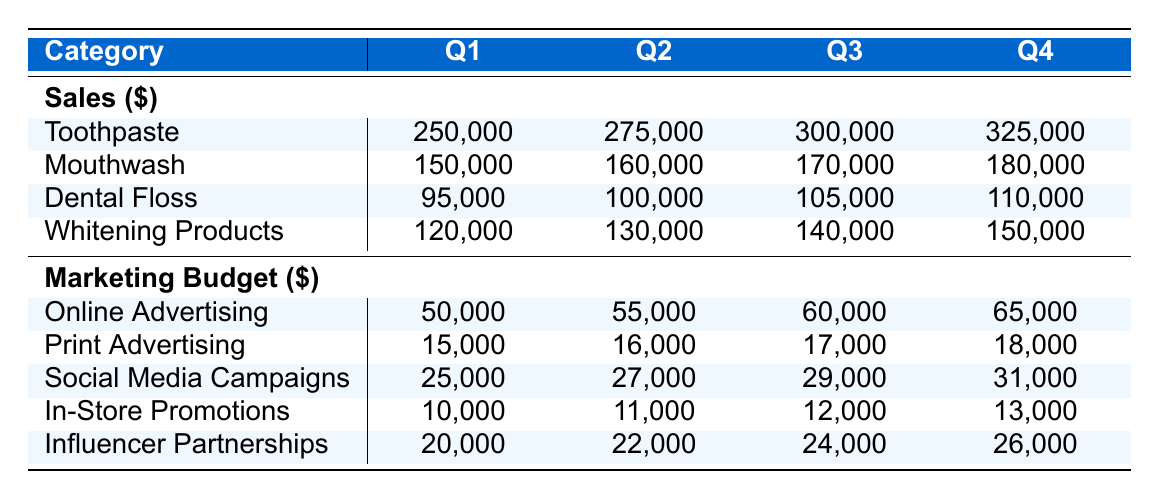What was the total sales for Toothpaste in Q2? To find the total sales for Toothpaste in Q2, locate the Q2 column in the Sales section and find the corresponding value for Toothpaste, which is 275,000.
Answer: 275,000 How much did the company spend on Online Advertising in Q3? In the Marketing Budget section, find the Q3 column and look at the row for Online Advertising. The value is 60,000.
Answer: 60,000 What is the total sales for Dental Floss over all quarters? To find the total sales for Dental Floss, add the sales from all four quarters: 95,000 (Q1) + 100,000 (Q2) + 105,000 (Q3) + 110,000 (Q4) = 410,000.
Answer: 410,000 Was the spending on In-Store Promotions higher in Q1 than in Q2? Check the In-Store Promotions row for both Q1 and Q2. In Q1, the spending was 10,000 and in Q2 it was 11,000. Since 10,000 is less than 11,000, the statement is false.
Answer: No What was the average spending on Social Media Campaigns throughout the year? To calculate the average spending on Social Media Campaigns, first find the values for each quarter: 25,000 (Q1) + 27,000 (Q2) + 29,000 (Q3) + 31,000 (Q4) = 112,000. Then divide by the number of quarters (4): 112,000 / 4 = 28,000.
Answer: 28,000 What is the difference in sales for Whitening Products between Q3 and Q1? To find the difference, look at the sales values for Whitening Products in both quarters: 140,000 (Q3) and 120,000 (Q1). Subtract Q1 from Q3: 140,000 - 120,000 = 20,000.
Answer: 20,000 Is the total marketing budget for Q4 greater than the total for Q1? Sum the Marketing Budget values for both quarters: For Q1 it is 50,000 + 15,000 + 25,000 + 10,000 + 20,000 = 120,000. For Q4, it is 65,000 + 18,000 + 31,000 + 13,000 + 26,000 = 153,000. Since 153,000 is greater than 120,000, the statement is true.
Answer: Yes How much did Mouthwash sales increase from Q1 to Q4? Find the sales for Mouthwash in both quarters: 150,000 (Q1) and 180,000 (Q4). To find the increase, subtract Q1 from Q4: 180,000 - 150,000 = 30,000.
Answer: 30,000 